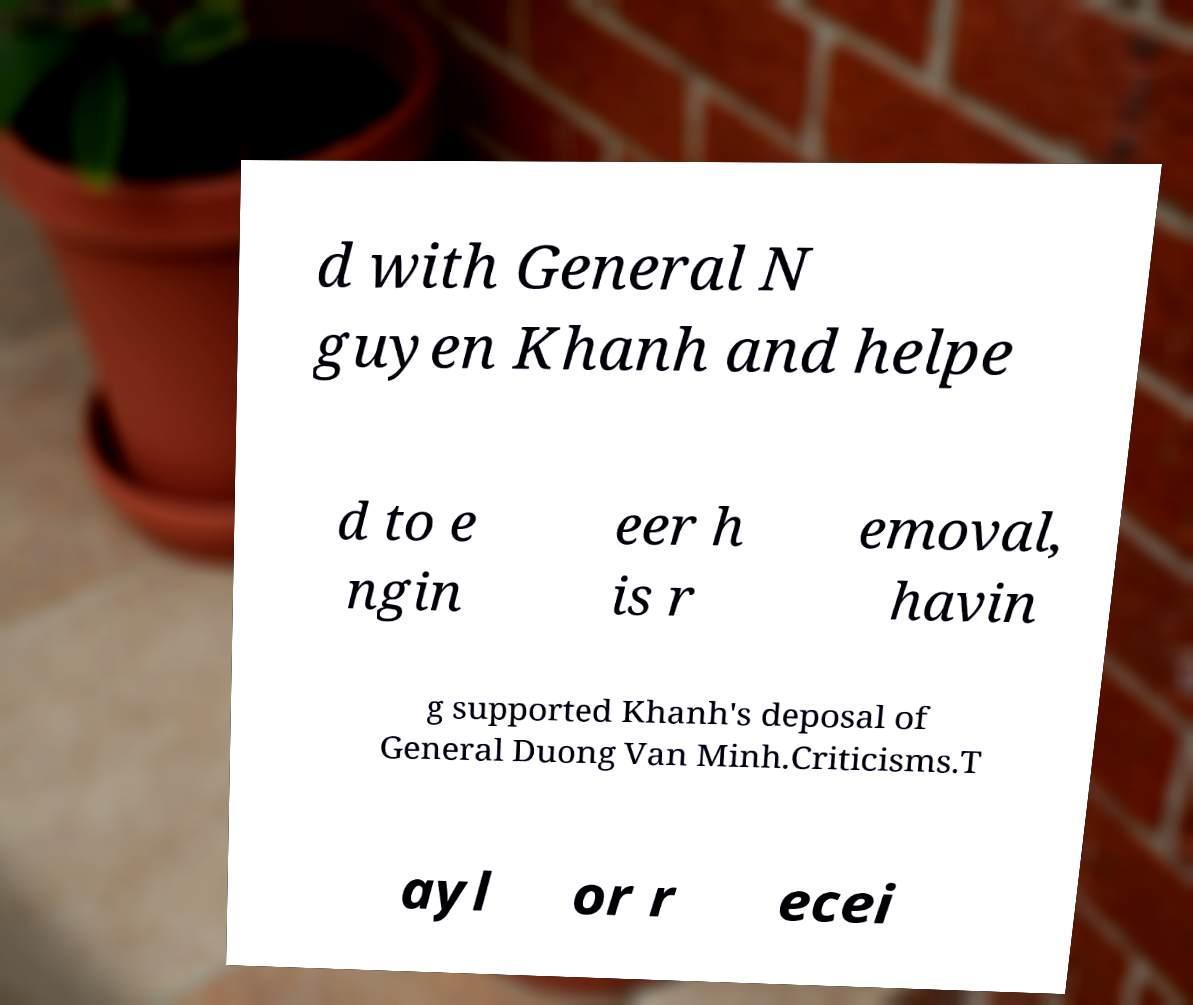Could you extract and type out the text from this image? d with General N guyen Khanh and helpe d to e ngin eer h is r emoval, havin g supported Khanh's deposal of General Duong Van Minh.Criticisms.T ayl or r ecei 